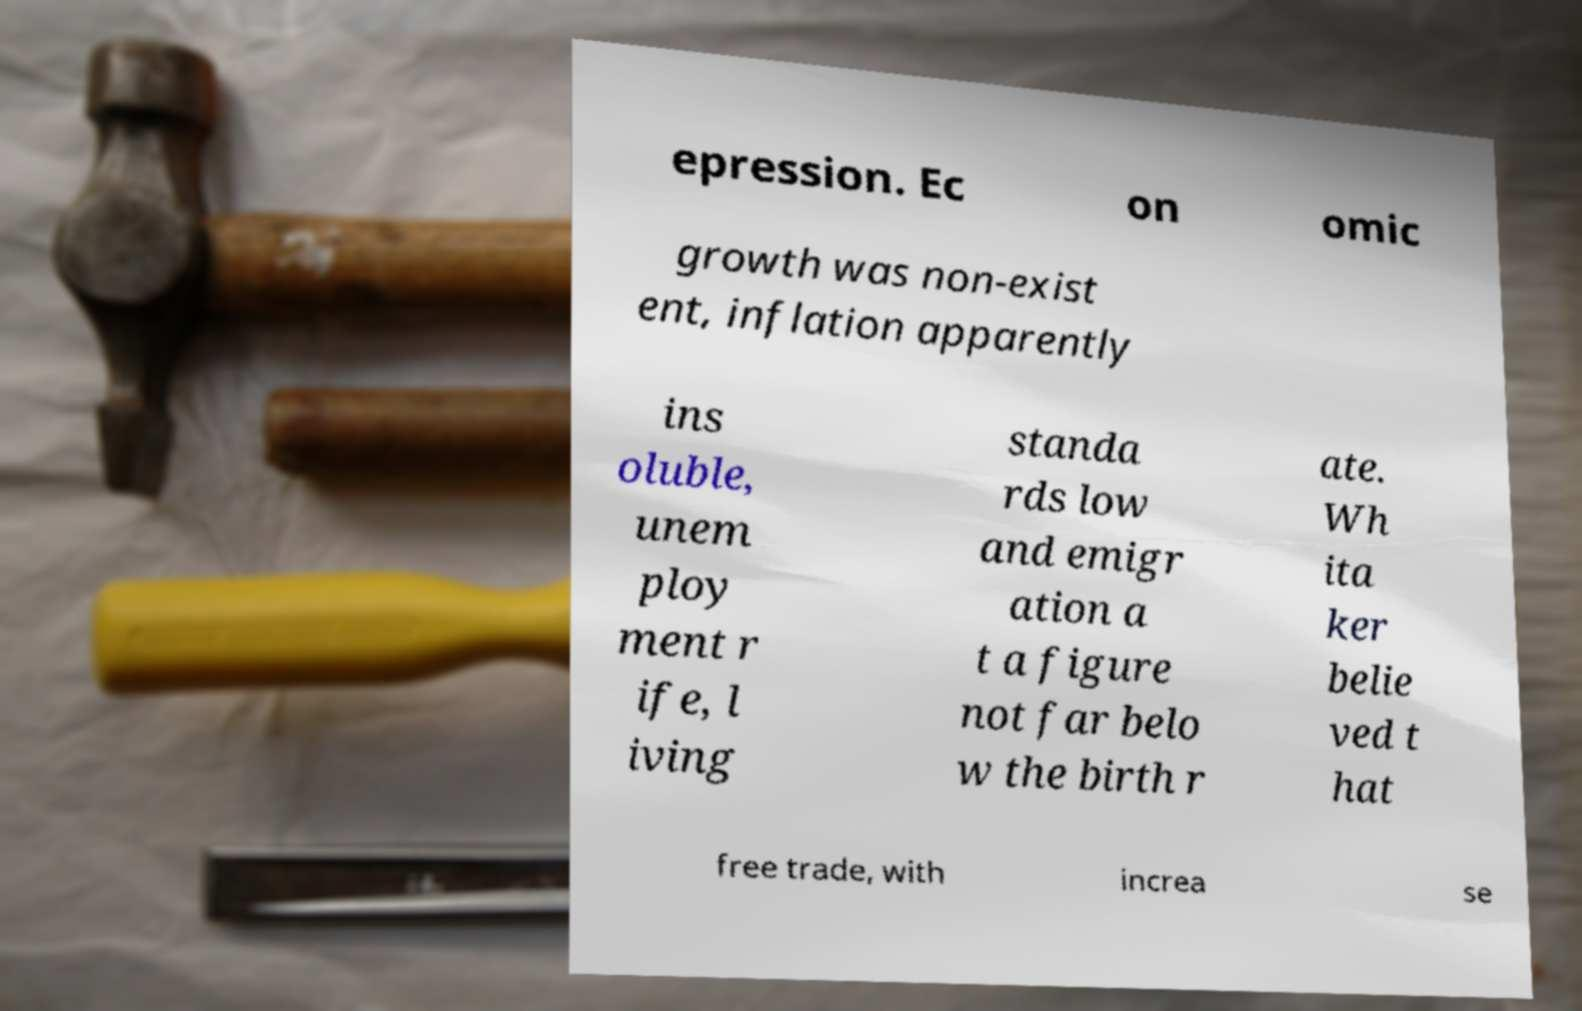Please read and relay the text visible in this image. What does it say? epression. Ec on omic growth was non-exist ent, inflation apparently ins oluble, unem ploy ment r ife, l iving standa rds low and emigr ation a t a figure not far belo w the birth r ate. Wh ita ker belie ved t hat free trade, with increa se 